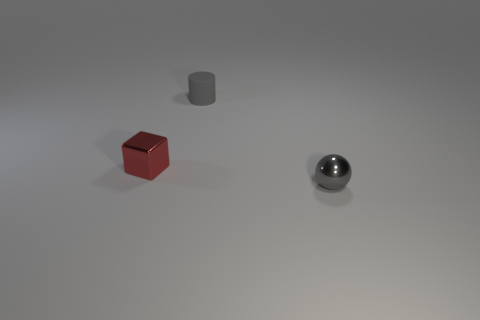Add 2 tiny shiny cylinders. How many objects exist? 5 Subtract all balls. How many objects are left? 2 Subtract 0 red cylinders. How many objects are left? 3 Subtract all red cubes. Subtract all tiny red objects. How many objects are left? 1 Add 2 small red metal things. How many small red metal things are left? 3 Add 2 small gray rubber cylinders. How many small gray rubber cylinders exist? 3 